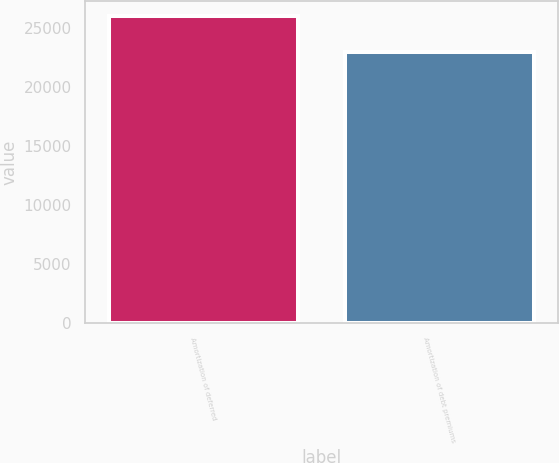Convert chart to OTSL. <chart><loc_0><loc_0><loc_500><loc_500><bar_chart><fcel>Amortization of deferred<fcel>Amortization of debt premiums<nl><fcel>26033<fcel>23000<nl></chart> 